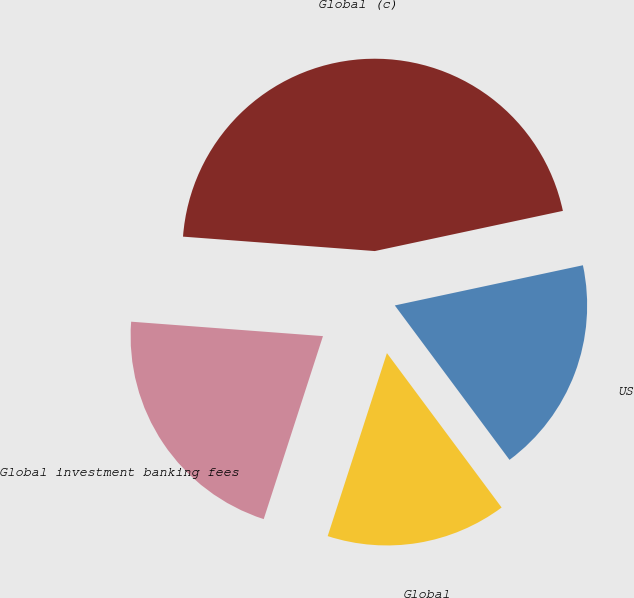Convert chart. <chart><loc_0><loc_0><loc_500><loc_500><pie_chart><fcel>Global<fcel>US<fcel>Global (c)<fcel>Global investment banking fees<nl><fcel>15.15%<fcel>18.18%<fcel>45.45%<fcel>21.21%<nl></chart> 